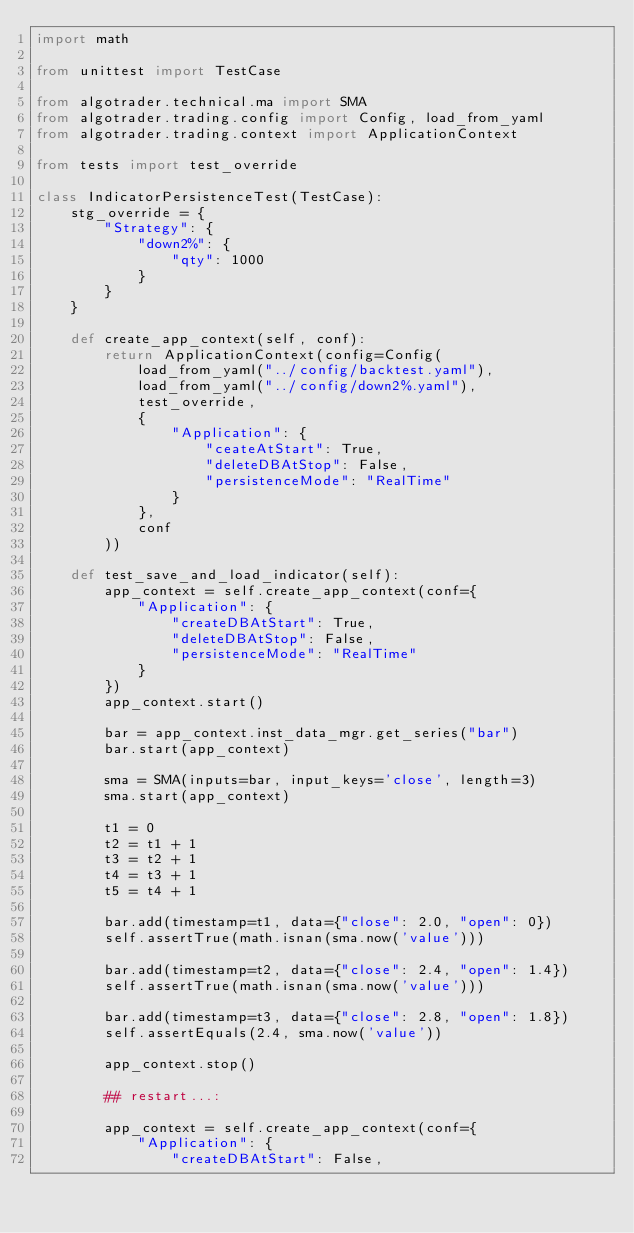Convert code to text. <code><loc_0><loc_0><loc_500><loc_500><_Python_>import math

from unittest import TestCase

from algotrader.technical.ma import SMA
from algotrader.trading.config import Config, load_from_yaml
from algotrader.trading.context import ApplicationContext

from tests import test_override

class IndicatorPersistenceTest(TestCase):
    stg_override = {
        "Strategy": {
            "down2%": {
                "qty": 1000
            }
        }
    }

    def create_app_context(self, conf):
        return ApplicationContext(config=Config(
            load_from_yaml("../config/backtest.yaml"),
            load_from_yaml("../config/down2%.yaml"),
            test_override,
            {
                "Application": {
                    "ceateAtStart": True,
                    "deleteDBAtStop": False,
                    "persistenceMode": "RealTime"
                }
            },
            conf
        ))

    def test_save_and_load_indicator(self):
        app_context = self.create_app_context(conf={
            "Application": {
                "createDBAtStart": True,
                "deleteDBAtStop": False,
                "persistenceMode": "RealTime"
            }
        })
        app_context.start()

        bar = app_context.inst_data_mgr.get_series("bar")
        bar.start(app_context)

        sma = SMA(inputs=bar, input_keys='close', length=3)
        sma.start(app_context)

        t1 = 0
        t2 = t1 + 1
        t3 = t2 + 1
        t4 = t3 + 1
        t5 = t4 + 1

        bar.add(timestamp=t1, data={"close": 2.0, "open": 0})
        self.assertTrue(math.isnan(sma.now('value')))

        bar.add(timestamp=t2, data={"close": 2.4, "open": 1.4})
        self.assertTrue(math.isnan(sma.now('value')))

        bar.add(timestamp=t3, data={"close": 2.8, "open": 1.8})
        self.assertEquals(2.4, sma.now('value'))

        app_context.stop()

        ## restart...:

        app_context = self.create_app_context(conf={
            "Application": {
                "createDBAtStart": False,</code> 